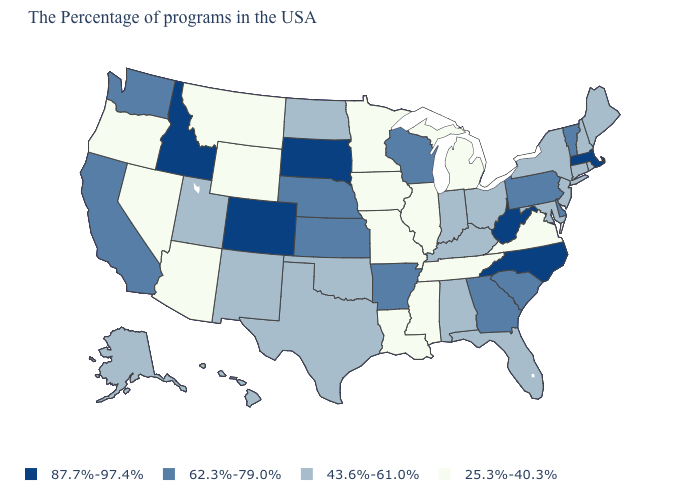Name the states that have a value in the range 87.7%-97.4%?
Concise answer only. Massachusetts, North Carolina, West Virginia, South Dakota, Colorado, Idaho. What is the lowest value in the USA?
Concise answer only. 25.3%-40.3%. What is the value of Massachusetts?
Give a very brief answer. 87.7%-97.4%. How many symbols are there in the legend?
Be succinct. 4. What is the value of Georgia?
Concise answer only. 62.3%-79.0%. Does Delaware have a lower value than Arizona?
Write a very short answer. No. Name the states that have a value in the range 43.6%-61.0%?
Answer briefly. Maine, Rhode Island, New Hampshire, Connecticut, New York, New Jersey, Maryland, Ohio, Florida, Kentucky, Indiana, Alabama, Oklahoma, Texas, North Dakota, New Mexico, Utah, Alaska, Hawaii. Which states hav the highest value in the Northeast?
Write a very short answer. Massachusetts. What is the value of Minnesota?
Write a very short answer. 25.3%-40.3%. Name the states that have a value in the range 62.3%-79.0%?
Quick response, please. Vermont, Delaware, Pennsylvania, South Carolina, Georgia, Wisconsin, Arkansas, Kansas, Nebraska, California, Washington. How many symbols are there in the legend?
Concise answer only. 4. Among the states that border South Carolina , does North Carolina have the highest value?
Keep it brief. Yes. What is the value of Wisconsin?
Give a very brief answer. 62.3%-79.0%. What is the value of Massachusetts?
Write a very short answer. 87.7%-97.4%. What is the lowest value in states that border Iowa?
Concise answer only. 25.3%-40.3%. 